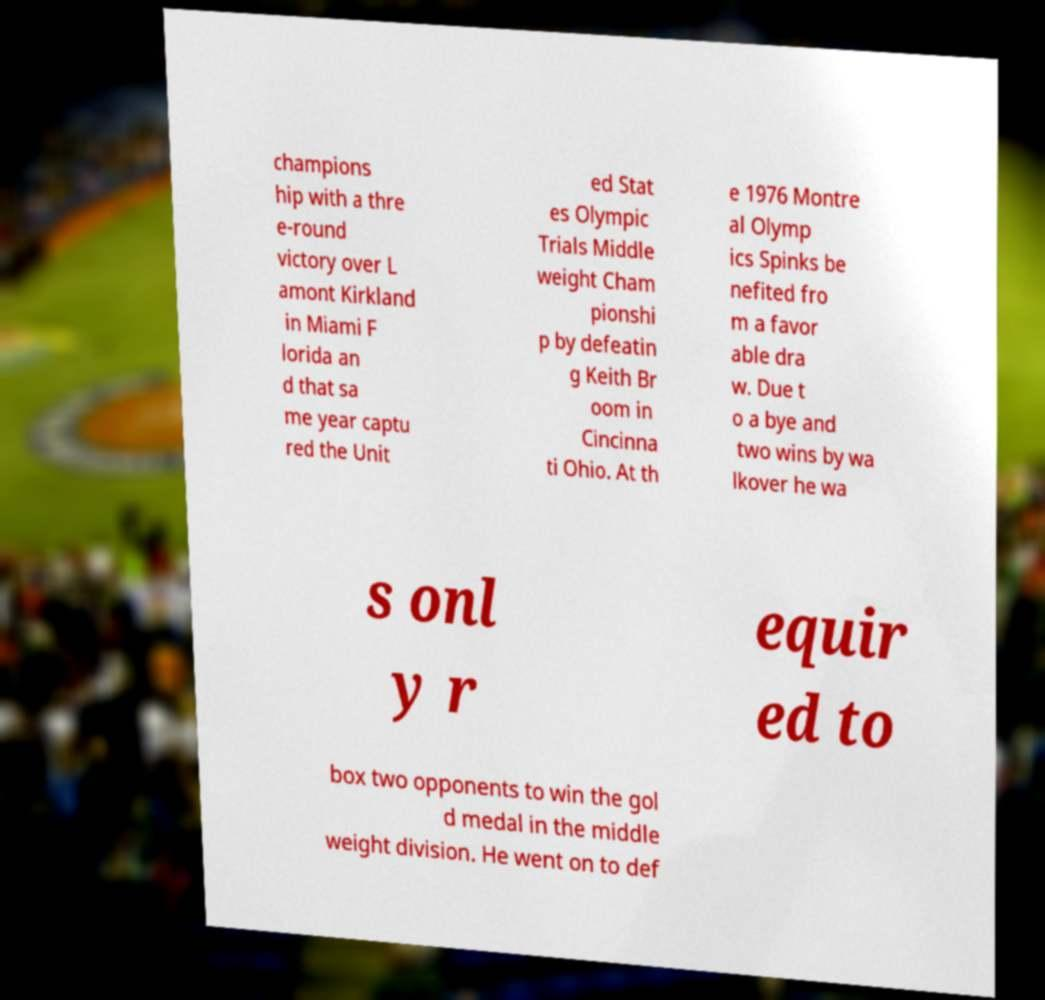Could you assist in decoding the text presented in this image and type it out clearly? champions hip with a thre e-round victory over L amont Kirkland in Miami F lorida an d that sa me year captu red the Unit ed Stat es Olympic Trials Middle weight Cham pionshi p by defeatin g Keith Br oom in Cincinna ti Ohio. At th e 1976 Montre al Olymp ics Spinks be nefited fro m a favor able dra w. Due t o a bye and two wins by wa lkover he wa s onl y r equir ed to box two opponents to win the gol d medal in the middle weight division. He went on to def 